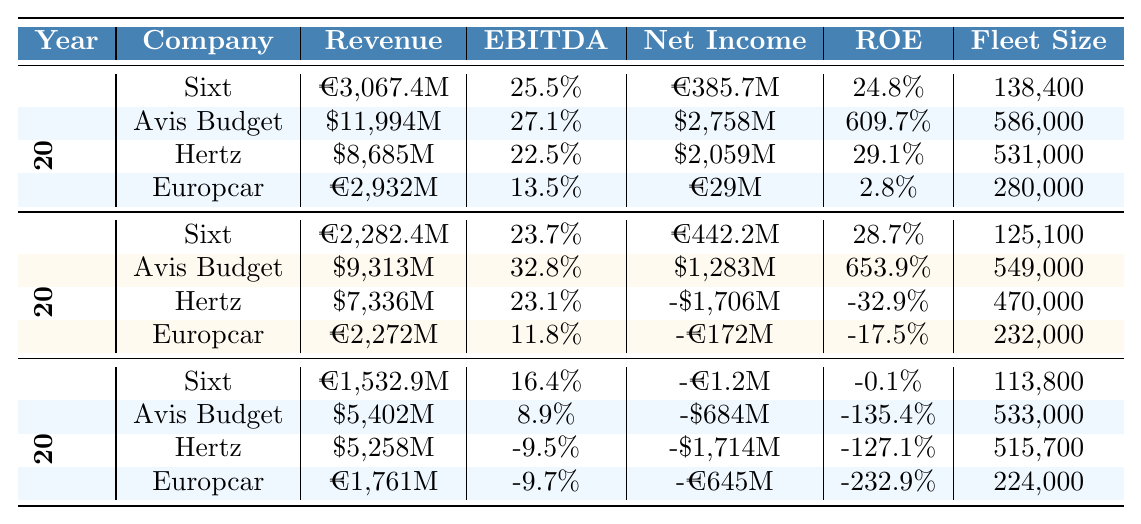What was Sixt's revenue in 2022? Referring to the table, Sixt's revenue in 2022 is listed as €3,067.4 million.
Answer: €3,067.4 million How much did Avis Budget Group earn in net income in 2021? According to the table, Avis Budget Group's net income in 2021 is reported as $1,283 million.
Answer: $1,283 million Which company had the highest EBITDA margin in 2022? The table shows Avis Budget Group with the highest EBITDA margin of 27.1% in 2022.
Answer: Avis Budget Group Is it true that Hertz had a negative net income in 2021? From the table data, Hertz's net income in 2021 was negative at -$1,706 million, confirming it as true.
Answer: Yes What is the average revenue of all companies in 2020? The revenues for 2020 are: Sixt (€1,532.9M), Avis Budget ($5,402M), Hertz ($5,258M), and Europcar (€1,761M). Converting all to euros for consistency: Avis Budget ($5,402M) is approximately €4,495.9M (using 1.2 exchange rate), and Hertz ($5,258M) is about €4,382.4M (using 1.2 exchange rate). Total revenue = €1,532.9M + €4,495.9M + €4,382.4M + €1,761M = €12,172.2M. The average revenue = €12,172.2M / 4 = €3,043.05 million.
Answer: €3,043.05 million Which company had the smallest fleet size in 2021? The table shows Sixt with a fleet size of 125,100, Avis Budget with 549,000, Hertz with 470,000, and Europcar with 232,000 in 2021. Thus, Sixt had the smallest fleet size.
Answer: Sixt What was the difference in Net Income between Sixt and Hertz in 2022? For 2022, Sixt's net income was €385.7 million, while Hertz's net income was $2,059 million, approximately €1,716 million (using 1.2 exchange rate). The difference = €1,716M - €0.386M = €1,715.6 million.
Answer: €1,715.6 million Did Sixt show an increase in total fleet size from 2020 to 2022? In 2020, Sixt's fleet size was 113,800, and in 2022 it was 138,400. The increase is 138,400 - 113,800 = 24,600, indicating an increase.
Answer: Yes What was the trend of EBITDA margins for Sixt from 2020 to 2022? The table presents Sixt's EBITDA margins as 16.4% (2020), 23.7% (2021), and 25.5% (2022). The margins show a steady increase year over year: 16.4% to 23.7% to 25.5%.
Answer: Increasing Which company's net income showed the most significant decline from 2020 to 2021? From the table, Hertz's net income in 2020 was -$1,714 million, and in 2021 it was -$1,706 million, showing a very slight improvement. Europcar, on the other hand, declined from -€645 million in 2020 to -€172 million in 2021, indicating an improvement in net income but not a decline. Therefore, Hertz did not show a decline; instead, the drastic decrease was in the overall net income.
Answer: Hertz What is the ratio of Sixt's revenue to Avis Budget Group's revenue in 2021? In 2021, Sixt reported revenue of €2,282.4 million and Avis Budget Group reported $9,313 million, approximately €7,760.8 million (using 1.2 exchange rate). The ratio = Sixt's revenue / Avis Budget's revenue = €2,282.4M / €7,760.8M = 0.2935, which is approximately 0.29.
Answer: 0.29 